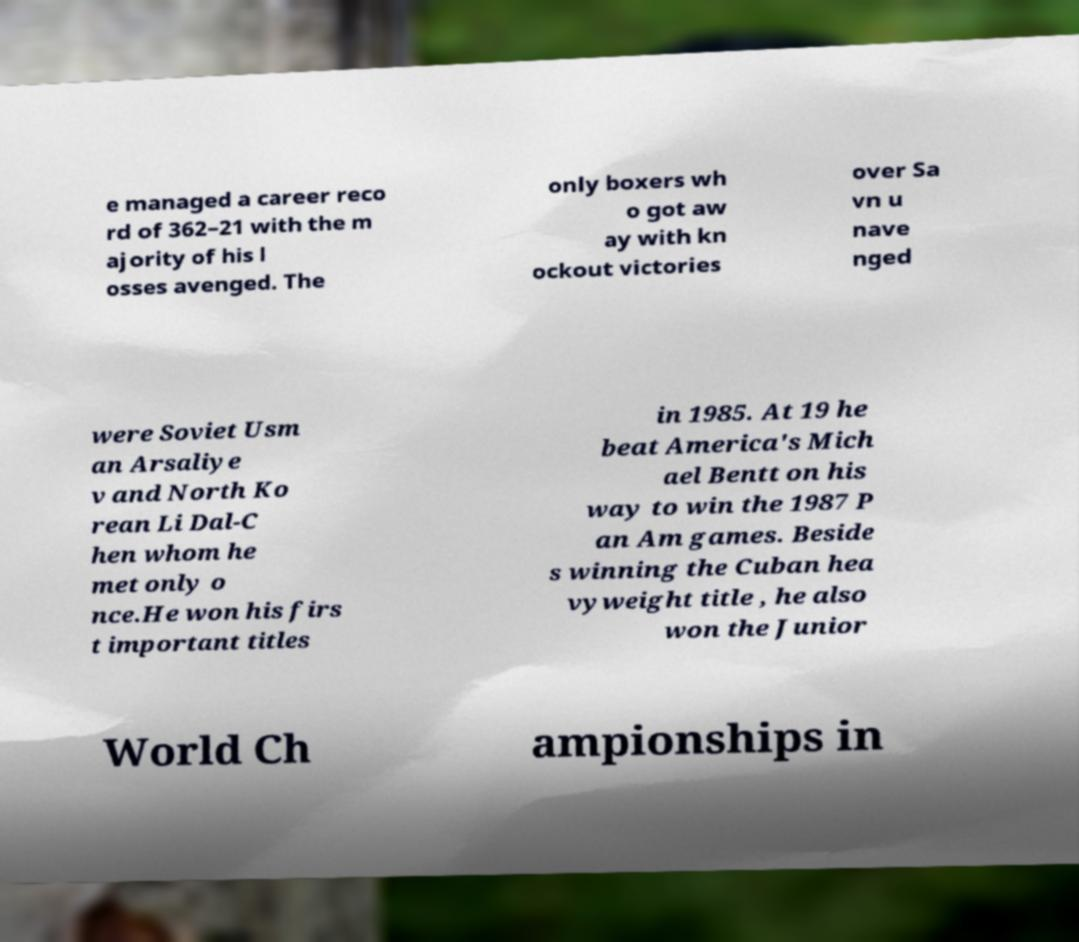Please identify and transcribe the text found in this image. e managed a career reco rd of 362–21 with the m ajority of his l osses avenged. The only boxers wh o got aw ay with kn ockout victories over Sa vn u nave nged were Soviet Usm an Arsaliye v and North Ko rean Li Dal-C hen whom he met only o nce.He won his firs t important titles in 1985. At 19 he beat America's Mich ael Bentt on his way to win the 1987 P an Am games. Beside s winning the Cuban hea vyweight title , he also won the Junior World Ch ampionships in 